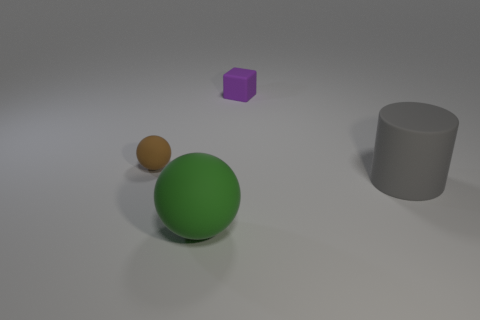Is there any other thing that has the same shape as the gray thing?
Ensure brevity in your answer.  No. How many small things are gray rubber cylinders or yellow matte things?
Make the answer very short. 0. Are there an equal number of brown rubber spheres behind the tiny brown rubber sphere and gray matte cubes?
Give a very brief answer. Yes. Is there a small purple matte cube on the left side of the matte sphere to the right of the tiny brown rubber object?
Your answer should be very brief. No. How many other objects are there of the same color as the tiny cube?
Provide a short and direct response. 0. The tiny cube has what color?
Provide a short and direct response. Purple. What size is the object that is left of the tiny purple object and behind the large green object?
Give a very brief answer. Small. What number of things are objects left of the tiny block or matte cylinders?
Provide a succinct answer. 3. What is the shape of the purple thing that is the same material as the cylinder?
Your answer should be very brief. Cube. What is the shape of the tiny purple thing?
Make the answer very short. Cube. 